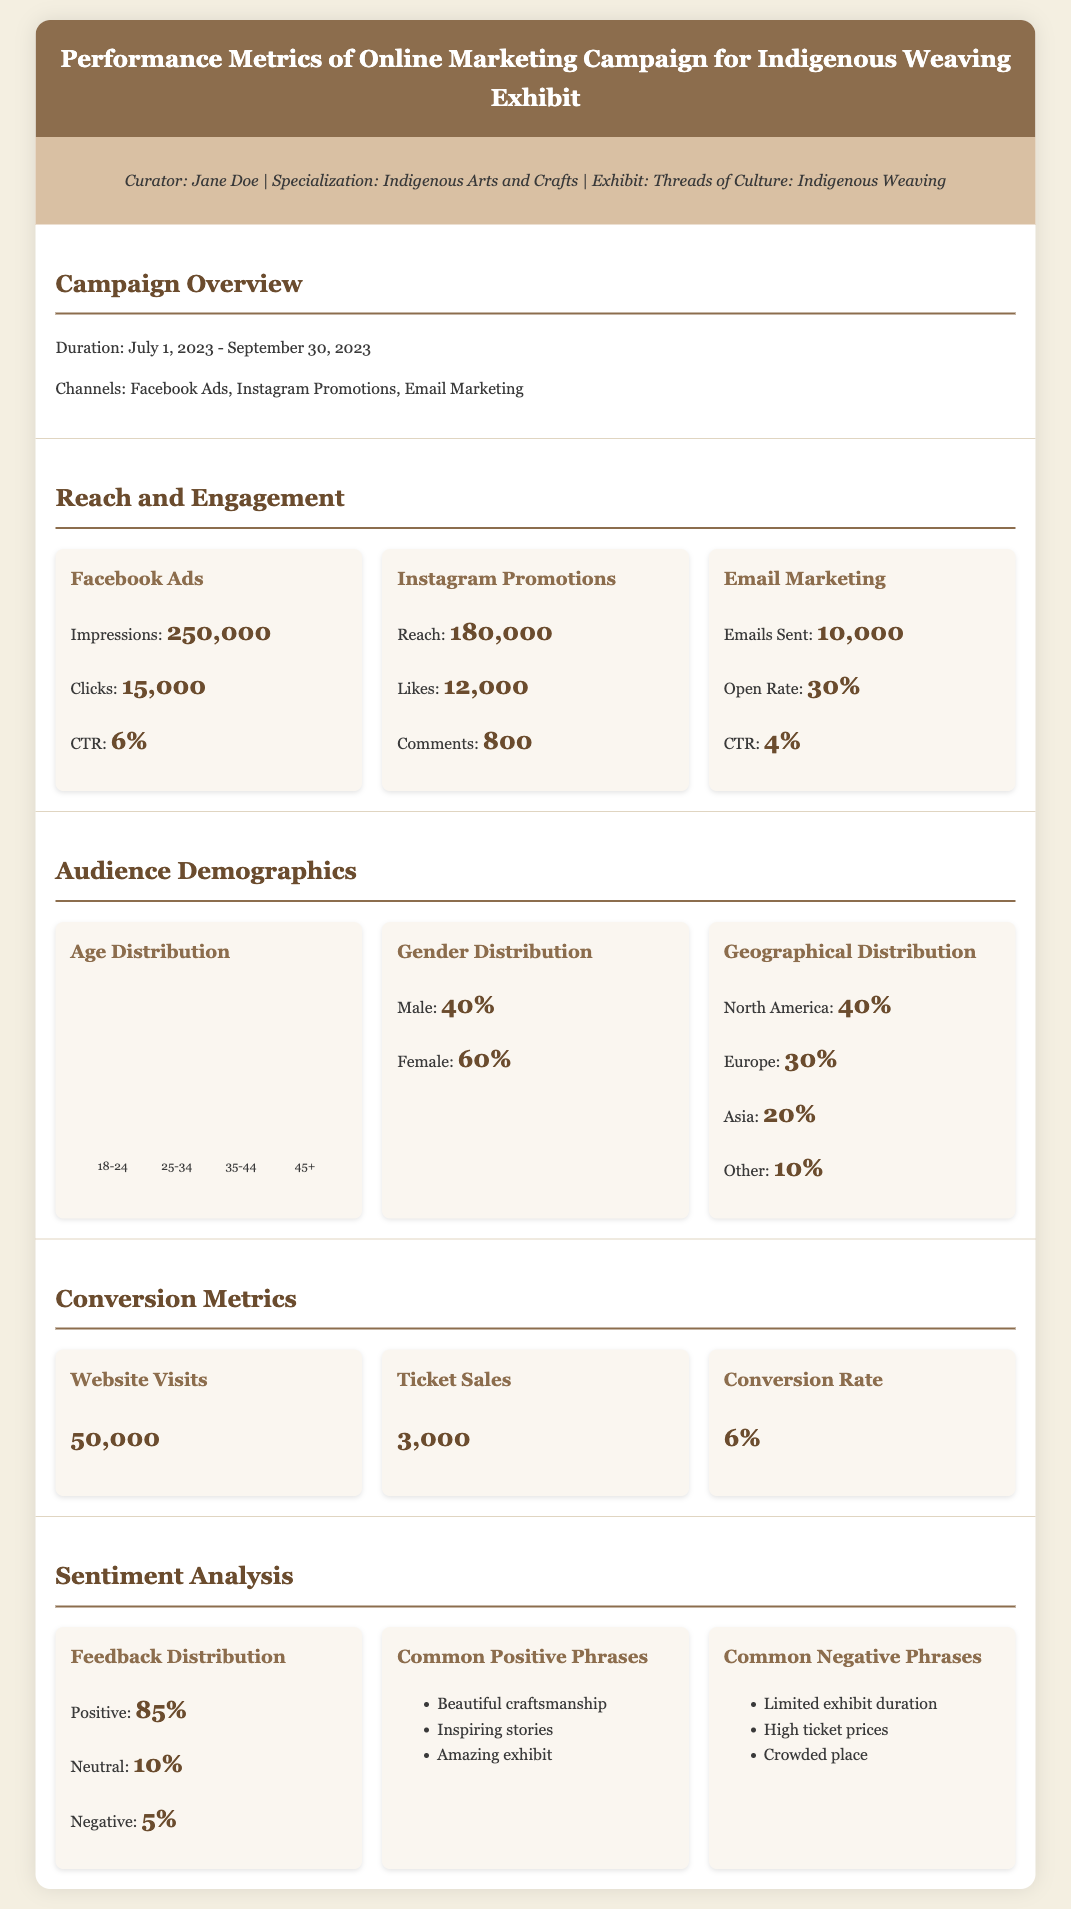What was the campaign duration? The campaign duration is specified in the overview section, which is from July 1, 2023 to September 30, 2023.
Answer: July 1, 2023 - September 30, 2023 How many impressions did the Facebook Ads receive? The number of impressions for Facebook Ads is detailed in the Reach and Engagement section.
Answer: 250,000 What is the conversion rate? The conversion rate is listed under Conversion Metrics in the document.
Answer: 6% Which social media channel had the highest engagement in terms of likes? The Instagram Promotions section lists the engagement metrics, and likes for Instagram exceeded those on Facebook Ads.
Answer: Instagram Promotions What percentage of feedback was positive? This information is provided in the Sentiment Analysis section, reflecting the overall customer sentiment.
Answer: 85% How many tickets were sold during the campaign? The number of ticket sales is mentioned in the Conversion Metrics section.
Answer: 3,000 What age group has the lowest representation in the campaign audience? The Age Distribution chart shows the representation percentages, and the lowest is for the age group 35-44.
Answer: 35-44 What is the geographical distribution percentage for Europe? The geographical distribution percentages are found in the Audience Demographics section, specifically listing Europe's percentage.
Answer: 30% 